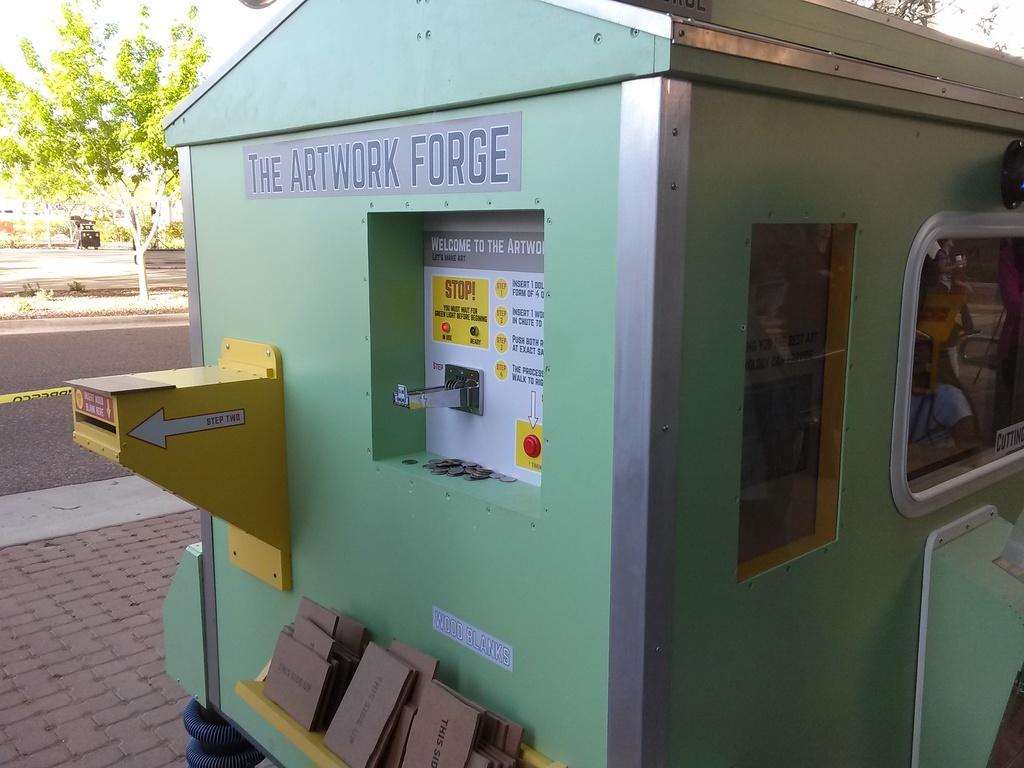<image>
Write a terse but informative summary of the picture. A green object is labeled The Artwork Forge. 